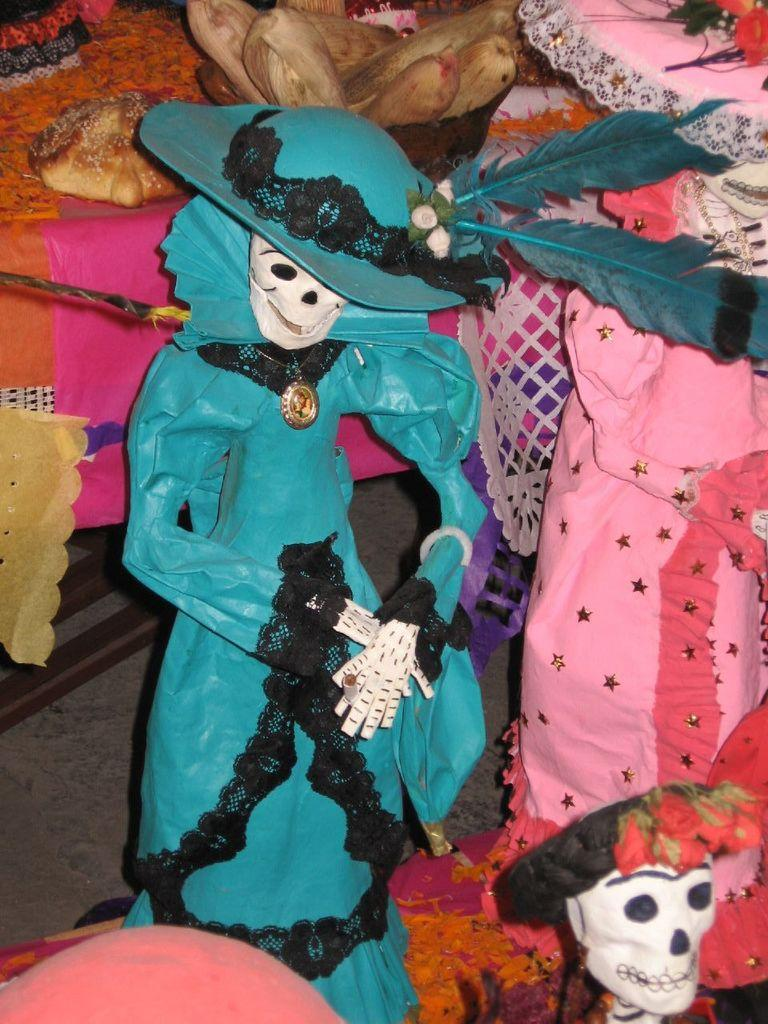What type of objects can be seen in the image? There are dolls in the image. What else can be seen in the background of the image? There are food items and flowers in the image. What other items are present in the image? There are clothes in the image. What is the surface on which the objects are placed? There is a floor at the bottom of the image. What type of cough medicine is the doctor prescribing in the image? There is no doctor or cough medicine present in the image. What direction is the zephyr blowing in the image? There is no mention of a zephyr or any wind in the image. 